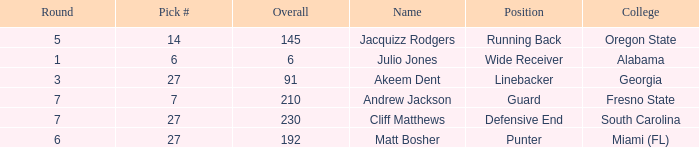Parse the full table. {'header': ['Round', 'Pick #', 'Overall', 'Name', 'Position', 'College'], 'rows': [['5', '14', '145', 'Jacquizz Rodgers', 'Running Back', 'Oregon State'], ['1', '6', '6', 'Julio Jones', 'Wide Receiver', 'Alabama'], ['3', '27', '91', 'Akeem Dent', 'Linebacker', 'Georgia'], ['7', '7', '210', 'Andrew Jackson', 'Guard', 'Fresno State'], ['7', '27', '230', 'Cliff Matthews', 'Defensive End', 'South Carolina'], ['6', '27', '192', 'Matt Bosher', 'Punter', 'Miami (FL)']]} Which highest pick number had Akeem Dent as a name and where the overall was less than 91? None. 